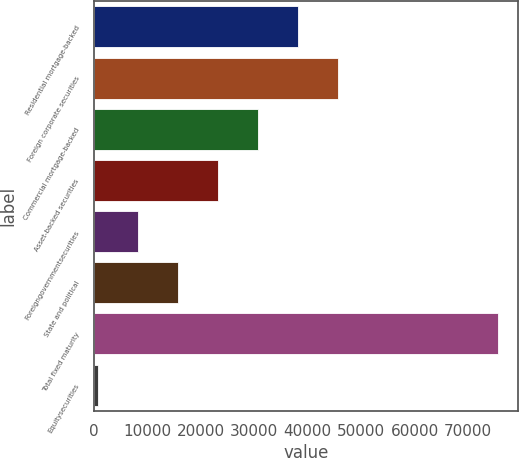<chart> <loc_0><loc_0><loc_500><loc_500><bar_chart><fcel>Residential mortgage-backed<fcel>Foreign corporate securities<fcel>Commercial mortgage-backed<fcel>Asset-backed securities<fcel>Foreigngovernmentsecurities<fcel>State and political<fcel>Total fixed maturity<fcel>Equitysecurities<nl><fcel>38165.5<fcel>45653.2<fcel>30677.8<fcel>23190.1<fcel>8214.7<fcel>15702.4<fcel>75604<fcel>727<nl></chart> 